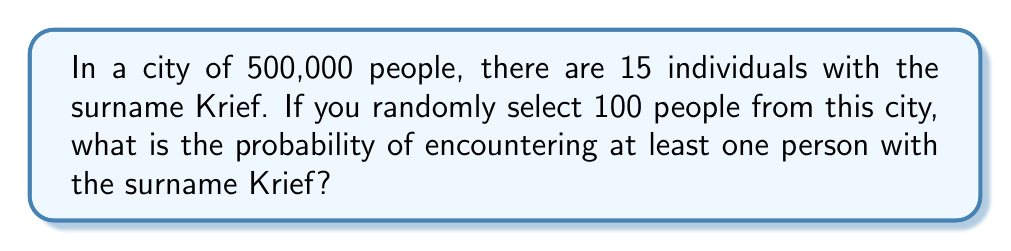Could you help me with this problem? Let's approach this step-by-step:

1) First, we need to calculate the probability of not selecting a Krief in a single draw:
   $P(\text{not Krief}) = \frac{500000 - 15}{500000} = 0.99997$

2) Now, we need to find the probability of not selecting any Kriefs in 100 draws. Since the population is large compared to our sample, we can treat each draw as independent:
   $P(\text{no Kriefs in 100 draws}) = (0.99997)^{100}$

3) We can calculate this:
   $(0.99997)^{100} \approx 0.9970$

4) The probability of encountering at least one Krief is the complement of not encountering any:
   $P(\text{at least one Krief}) = 1 - P(\text{no Kriefs})$
   $= 1 - 0.9970 = 0.0030$

5) Convert to a percentage:
   $0.0030 \times 100\% = 0.30\%$

Therefore, the probability of encountering at least one person with the surname Krief in a random sample of 100 people is approximately 0.30%.
Answer: 0.30% 